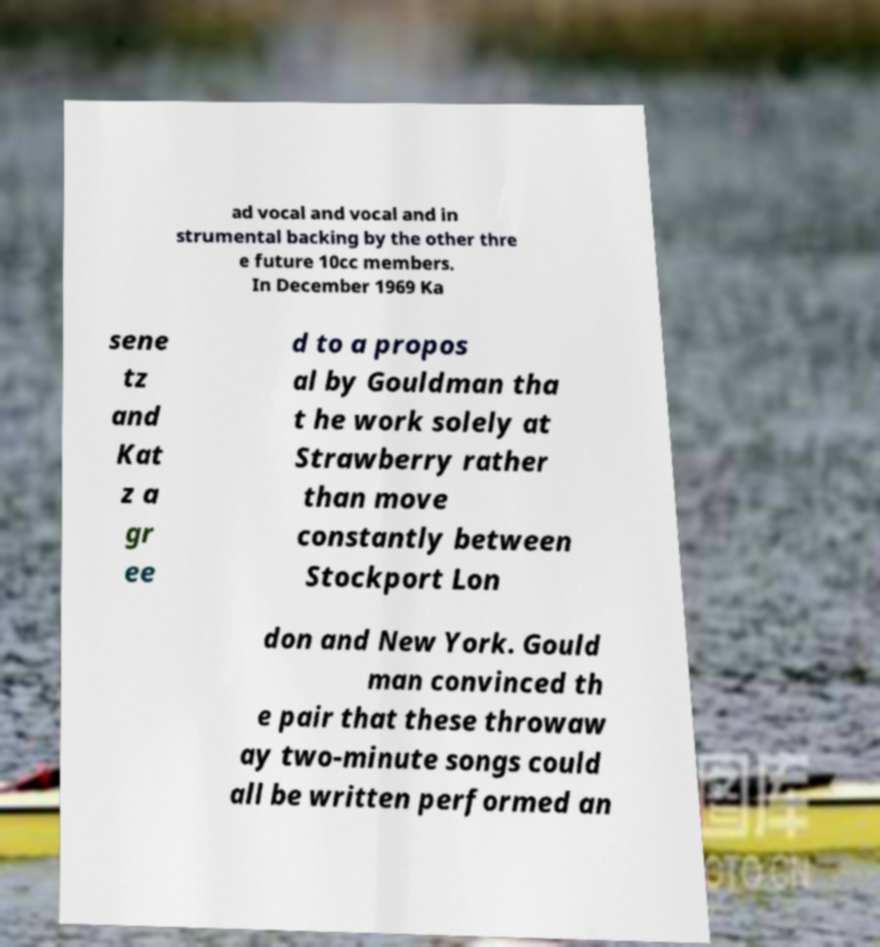I need the written content from this picture converted into text. Can you do that? ad vocal and vocal and in strumental backing by the other thre e future 10cc members. In December 1969 Ka sene tz and Kat z a gr ee d to a propos al by Gouldman tha t he work solely at Strawberry rather than move constantly between Stockport Lon don and New York. Gould man convinced th e pair that these throwaw ay two-minute songs could all be written performed an 